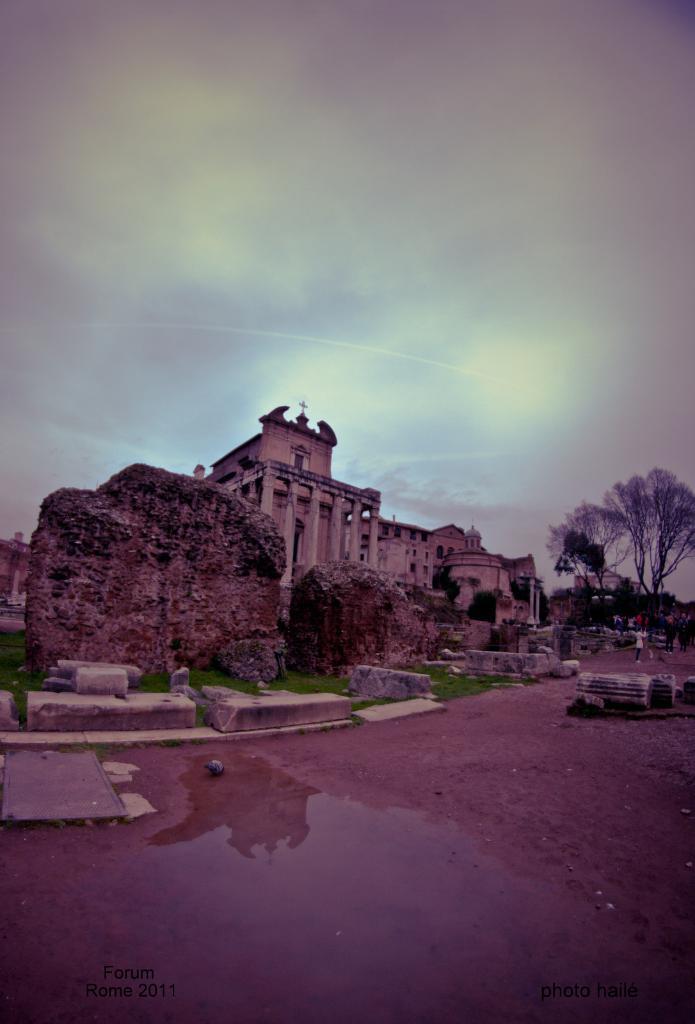Please provide a concise description of this image. In this image, I can see a building, rocks and trees. At the bottom of the image, I can see the water and the watermarks on the image. At the top of the image, this is the sky. On the right side of the image, there are few people standing. 